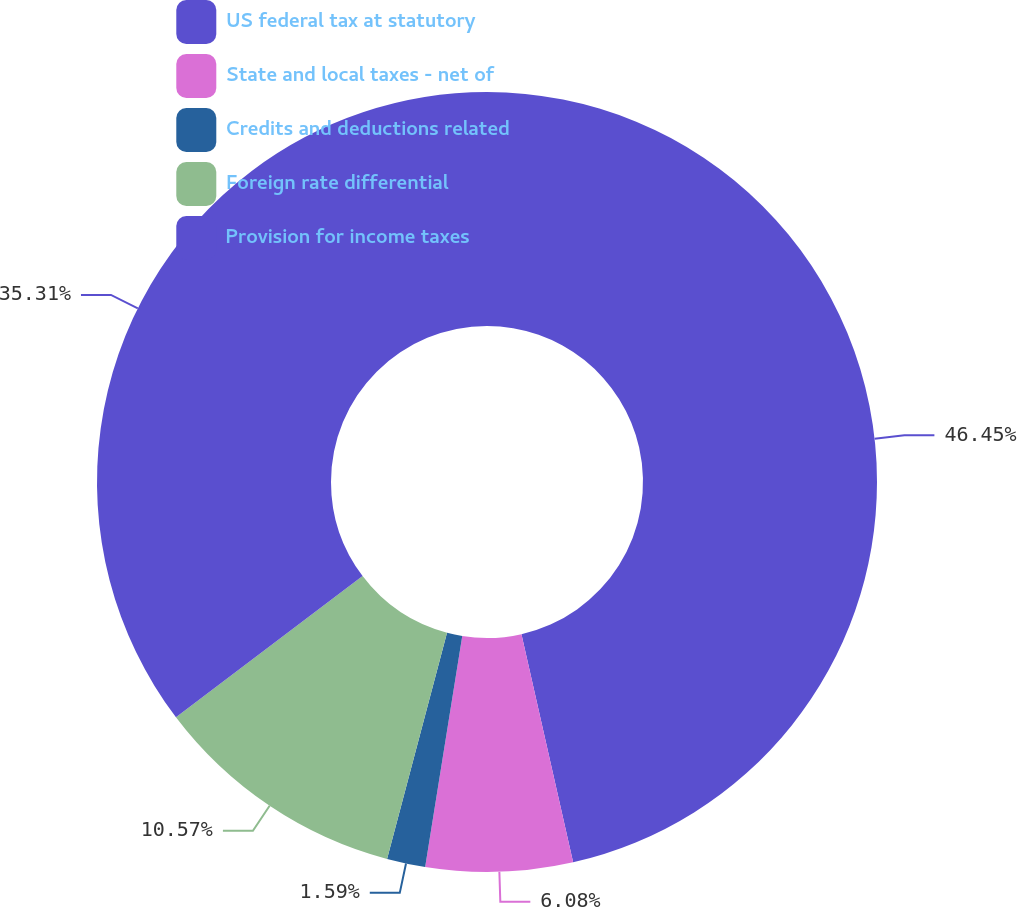Convert chart. <chart><loc_0><loc_0><loc_500><loc_500><pie_chart><fcel>US federal tax at statutory<fcel>State and local taxes - net of<fcel>Credits and deductions related<fcel>Foreign rate differential<fcel>Provision for income taxes<nl><fcel>46.46%<fcel>6.08%<fcel>1.59%<fcel>10.57%<fcel>35.31%<nl></chart> 